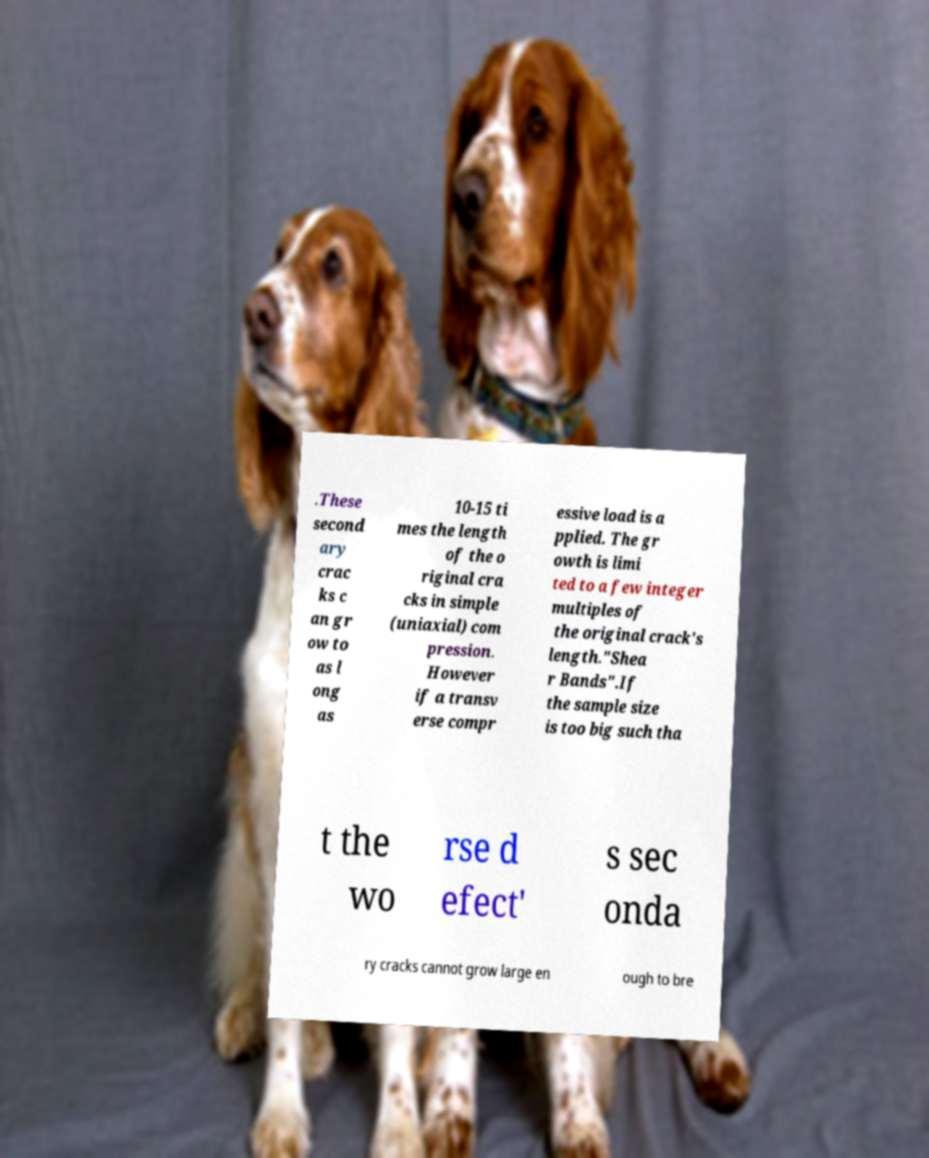What messages or text are displayed in this image? I need them in a readable, typed format. .These second ary crac ks c an gr ow to as l ong as 10-15 ti mes the length of the o riginal cra cks in simple (uniaxial) com pression. However if a transv erse compr essive load is a pplied. The gr owth is limi ted to a few integer multiples of the original crack's length."Shea r Bands".If the sample size is too big such tha t the wo rse d efect' s sec onda ry cracks cannot grow large en ough to bre 